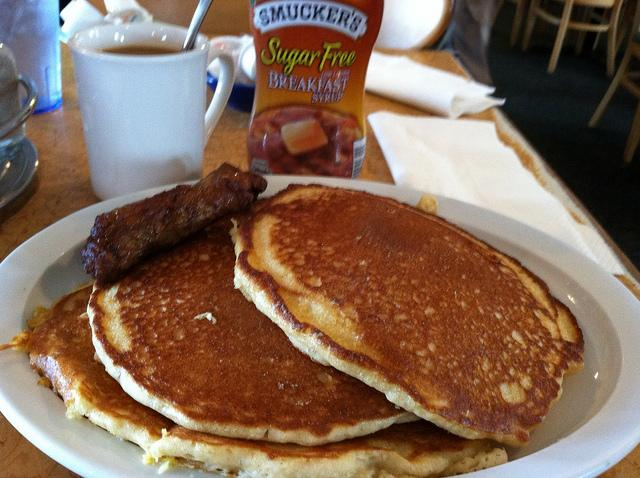What is the Smucker's product replacing?

Choices:
A) corn syrup
B) date syrup
C) maple syrup
D) agave nectar maple syrup 